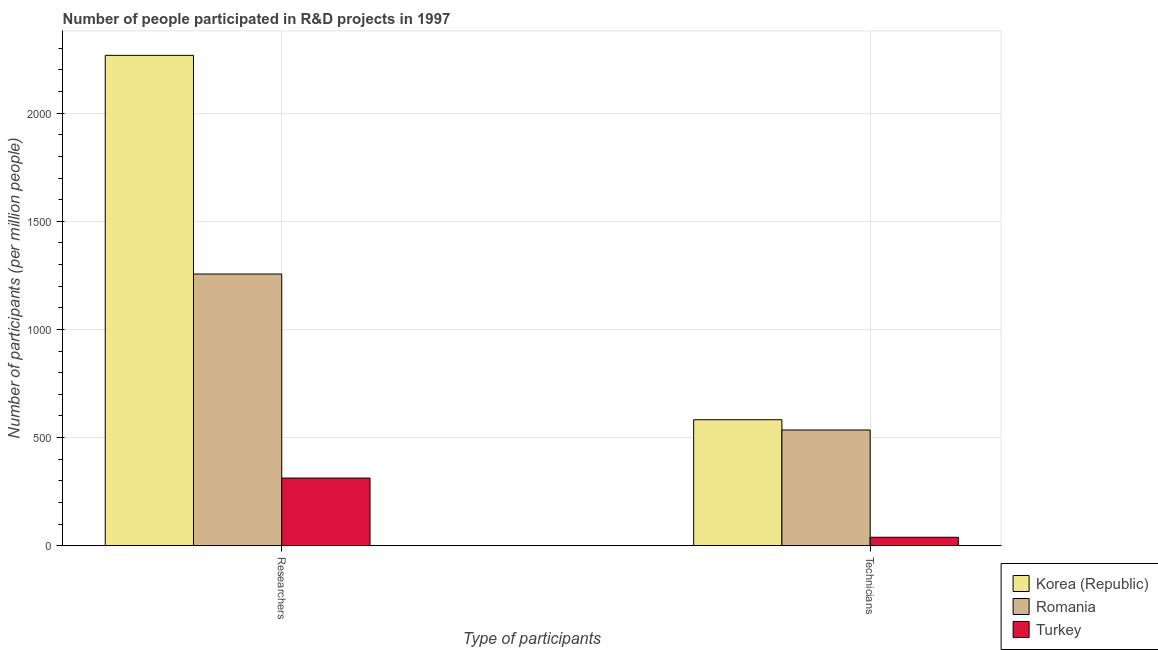How many groups of bars are there?
Provide a short and direct response. 2. Are the number of bars per tick equal to the number of legend labels?
Your response must be concise. Yes. How many bars are there on the 2nd tick from the right?
Your response must be concise. 3. What is the label of the 2nd group of bars from the left?
Ensure brevity in your answer.  Technicians. What is the number of technicians in Korea (Republic)?
Provide a short and direct response. 582.66. Across all countries, what is the maximum number of technicians?
Your answer should be very brief. 582.66. Across all countries, what is the minimum number of technicians?
Your answer should be compact. 39.29. In which country was the number of technicians maximum?
Make the answer very short. Korea (Republic). What is the total number of technicians in the graph?
Offer a terse response. 1157.18. What is the difference between the number of technicians in Korea (Republic) and that in Turkey?
Make the answer very short. 543.36. What is the difference between the number of researchers in Korea (Republic) and the number of technicians in Turkey?
Give a very brief answer. 2227.74. What is the average number of technicians per country?
Provide a short and direct response. 385.73. What is the difference between the number of technicians and number of researchers in Turkey?
Your answer should be compact. -273.79. What is the ratio of the number of technicians in Korea (Republic) to that in Turkey?
Your response must be concise. 14.83. What does the 2nd bar from the right in Researchers represents?
Give a very brief answer. Romania. How many bars are there?
Give a very brief answer. 6. Are all the bars in the graph horizontal?
Offer a terse response. No. What is the difference between two consecutive major ticks on the Y-axis?
Your response must be concise. 500. Are the values on the major ticks of Y-axis written in scientific E-notation?
Give a very brief answer. No. What is the title of the graph?
Provide a short and direct response. Number of people participated in R&D projects in 1997. What is the label or title of the X-axis?
Give a very brief answer. Type of participants. What is the label or title of the Y-axis?
Your response must be concise. Number of participants (per million people). What is the Number of participants (per million people) of Korea (Republic) in Researchers?
Offer a terse response. 2267.03. What is the Number of participants (per million people) of Romania in Researchers?
Your response must be concise. 1256.15. What is the Number of participants (per million people) of Turkey in Researchers?
Provide a short and direct response. 313.08. What is the Number of participants (per million people) in Korea (Republic) in Technicians?
Your answer should be very brief. 582.66. What is the Number of participants (per million people) of Romania in Technicians?
Your response must be concise. 535.23. What is the Number of participants (per million people) in Turkey in Technicians?
Provide a short and direct response. 39.29. Across all Type of participants, what is the maximum Number of participants (per million people) in Korea (Republic)?
Provide a short and direct response. 2267.03. Across all Type of participants, what is the maximum Number of participants (per million people) in Romania?
Give a very brief answer. 1256.15. Across all Type of participants, what is the maximum Number of participants (per million people) of Turkey?
Your response must be concise. 313.08. Across all Type of participants, what is the minimum Number of participants (per million people) of Korea (Republic)?
Provide a succinct answer. 582.66. Across all Type of participants, what is the minimum Number of participants (per million people) in Romania?
Provide a succinct answer. 535.23. Across all Type of participants, what is the minimum Number of participants (per million people) of Turkey?
Keep it short and to the point. 39.29. What is the total Number of participants (per million people) of Korea (Republic) in the graph?
Your answer should be very brief. 2849.69. What is the total Number of participants (per million people) in Romania in the graph?
Offer a very short reply. 1791.38. What is the total Number of participants (per million people) in Turkey in the graph?
Offer a terse response. 352.37. What is the difference between the Number of participants (per million people) in Korea (Republic) in Researchers and that in Technicians?
Offer a very short reply. 1684.37. What is the difference between the Number of participants (per million people) of Romania in Researchers and that in Technicians?
Make the answer very short. 720.93. What is the difference between the Number of participants (per million people) of Turkey in Researchers and that in Technicians?
Give a very brief answer. 273.79. What is the difference between the Number of participants (per million people) in Korea (Republic) in Researchers and the Number of participants (per million people) in Romania in Technicians?
Your answer should be compact. 1731.8. What is the difference between the Number of participants (per million people) of Korea (Republic) in Researchers and the Number of participants (per million people) of Turkey in Technicians?
Offer a terse response. 2227.74. What is the difference between the Number of participants (per million people) of Romania in Researchers and the Number of participants (per million people) of Turkey in Technicians?
Your answer should be very brief. 1216.86. What is the average Number of participants (per million people) of Korea (Republic) per Type of participants?
Your answer should be compact. 1424.84. What is the average Number of participants (per million people) in Romania per Type of participants?
Provide a short and direct response. 895.69. What is the average Number of participants (per million people) of Turkey per Type of participants?
Provide a short and direct response. 176.18. What is the difference between the Number of participants (per million people) in Korea (Republic) and Number of participants (per million people) in Romania in Researchers?
Make the answer very short. 1010.88. What is the difference between the Number of participants (per million people) of Korea (Republic) and Number of participants (per million people) of Turkey in Researchers?
Offer a very short reply. 1953.95. What is the difference between the Number of participants (per million people) in Romania and Number of participants (per million people) in Turkey in Researchers?
Give a very brief answer. 943.08. What is the difference between the Number of participants (per million people) in Korea (Republic) and Number of participants (per million people) in Romania in Technicians?
Your answer should be compact. 47.43. What is the difference between the Number of participants (per million people) of Korea (Republic) and Number of participants (per million people) of Turkey in Technicians?
Your answer should be compact. 543.37. What is the difference between the Number of participants (per million people) of Romania and Number of participants (per million people) of Turkey in Technicians?
Give a very brief answer. 495.93. What is the ratio of the Number of participants (per million people) in Korea (Republic) in Researchers to that in Technicians?
Your answer should be very brief. 3.89. What is the ratio of the Number of participants (per million people) of Romania in Researchers to that in Technicians?
Your answer should be very brief. 2.35. What is the ratio of the Number of participants (per million people) of Turkey in Researchers to that in Technicians?
Make the answer very short. 7.97. What is the difference between the highest and the second highest Number of participants (per million people) of Korea (Republic)?
Provide a succinct answer. 1684.37. What is the difference between the highest and the second highest Number of participants (per million people) in Romania?
Provide a succinct answer. 720.93. What is the difference between the highest and the second highest Number of participants (per million people) of Turkey?
Offer a very short reply. 273.79. What is the difference between the highest and the lowest Number of participants (per million people) of Korea (Republic)?
Your answer should be compact. 1684.37. What is the difference between the highest and the lowest Number of participants (per million people) in Romania?
Your answer should be compact. 720.93. What is the difference between the highest and the lowest Number of participants (per million people) in Turkey?
Provide a succinct answer. 273.79. 